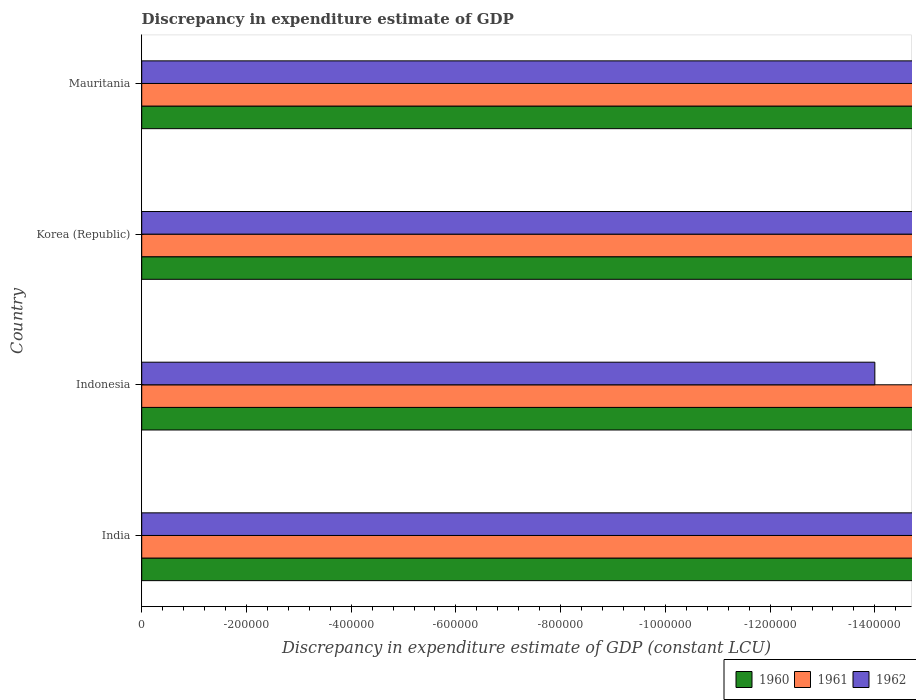How many different coloured bars are there?
Provide a short and direct response. 0. Are the number of bars on each tick of the Y-axis equal?
Make the answer very short. Yes. How many bars are there on the 1st tick from the bottom?
Ensure brevity in your answer.  0. What is the label of the 2nd group of bars from the top?
Offer a very short reply. Korea (Republic). In how many cases, is the number of bars for a given country not equal to the number of legend labels?
Your answer should be very brief. 4. What is the discrepancy in expenditure estimate of GDP in 1960 in Mauritania?
Ensure brevity in your answer.  0. What is the total discrepancy in expenditure estimate of GDP in 1960 in the graph?
Your answer should be compact. 0. What is the average discrepancy in expenditure estimate of GDP in 1961 per country?
Ensure brevity in your answer.  0. In how many countries, is the discrepancy in expenditure estimate of GDP in 1961 greater than the average discrepancy in expenditure estimate of GDP in 1961 taken over all countries?
Offer a terse response. 0. How many bars are there?
Provide a succinct answer. 0. How many countries are there in the graph?
Your answer should be very brief. 4. What is the difference between two consecutive major ticks on the X-axis?
Your answer should be compact. 2.00e+05. Are the values on the major ticks of X-axis written in scientific E-notation?
Make the answer very short. No. Where does the legend appear in the graph?
Keep it short and to the point. Bottom right. What is the title of the graph?
Your answer should be compact. Discrepancy in expenditure estimate of GDP. What is the label or title of the X-axis?
Offer a very short reply. Discrepancy in expenditure estimate of GDP (constant LCU). What is the label or title of the Y-axis?
Provide a succinct answer. Country. What is the Discrepancy in expenditure estimate of GDP (constant LCU) of 1962 in India?
Offer a very short reply. 0. What is the Discrepancy in expenditure estimate of GDP (constant LCU) in 1961 in Korea (Republic)?
Your response must be concise. 0. What is the Discrepancy in expenditure estimate of GDP (constant LCU) of 1962 in Korea (Republic)?
Offer a very short reply. 0. What is the Discrepancy in expenditure estimate of GDP (constant LCU) of 1962 in Mauritania?
Give a very brief answer. 0. What is the total Discrepancy in expenditure estimate of GDP (constant LCU) of 1960 in the graph?
Make the answer very short. 0. What is the total Discrepancy in expenditure estimate of GDP (constant LCU) in 1961 in the graph?
Provide a succinct answer. 0. What is the average Discrepancy in expenditure estimate of GDP (constant LCU) in 1960 per country?
Provide a short and direct response. 0. What is the average Discrepancy in expenditure estimate of GDP (constant LCU) in 1961 per country?
Offer a very short reply. 0. 